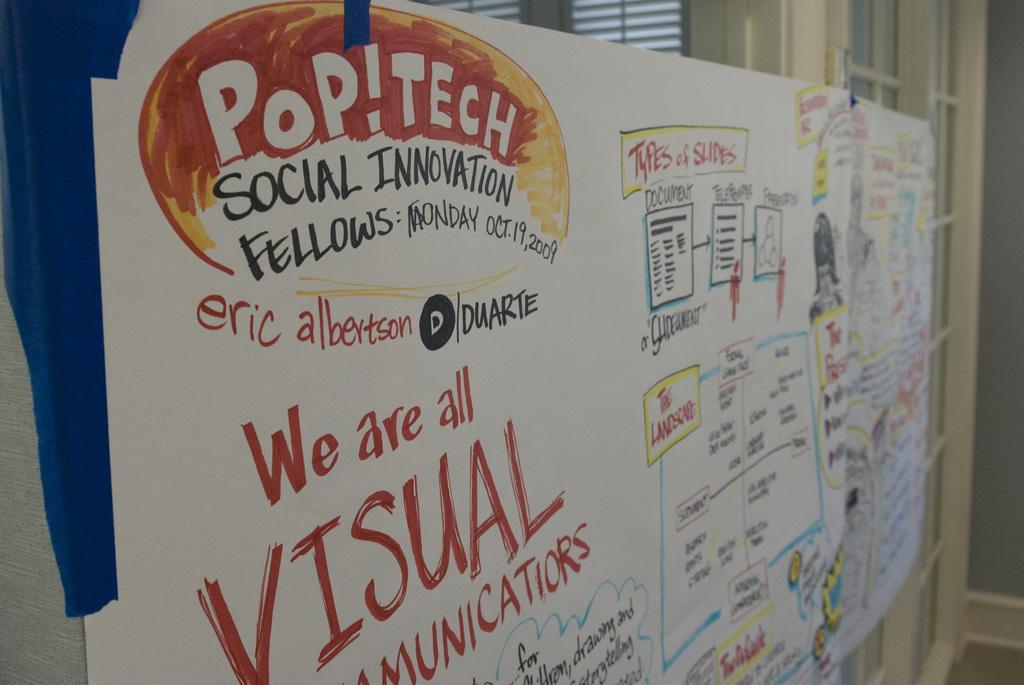How would you summarize this image in a sentence or two? In this image we can see a white board with some text. In the background there are doors and blinds. 